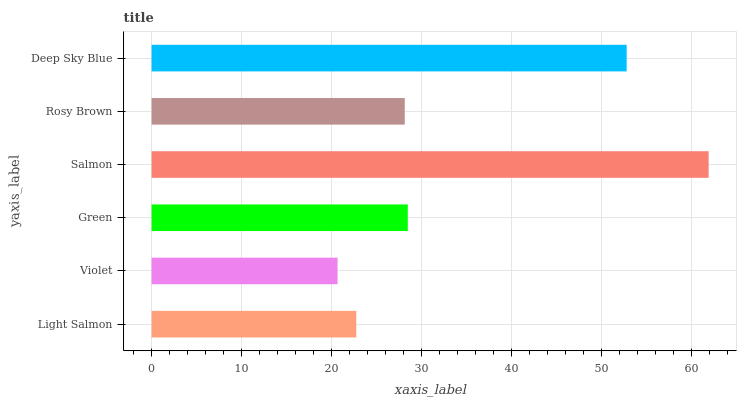Is Violet the minimum?
Answer yes or no. Yes. Is Salmon the maximum?
Answer yes or no. Yes. Is Green the minimum?
Answer yes or no. No. Is Green the maximum?
Answer yes or no. No. Is Green greater than Violet?
Answer yes or no. Yes. Is Violet less than Green?
Answer yes or no. Yes. Is Violet greater than Green?
Answer yes or no. No. Is Green less than Violet?
Answer yes or no. No. Is Green the high median?
Answer yes or no. Yes. Is Rosy Brown the low median?
Answer yes or no. Yes. Is Deep Sky Blue the high median?
Answer yes or no. No. Is Green the low median?
Answer yes or no. No. 